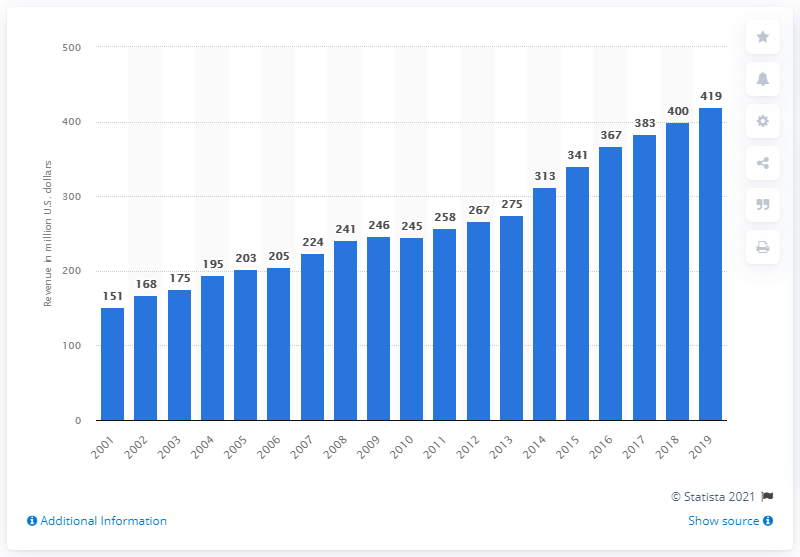Can you explain the trend in revenue growth for the Tampa Bay Buccaneers over the last decade? The chart displays a steady increase in revenue for the Tampa Bay Buccaneers over the last decade, growing from 267 million dollars in 2011 to 419 million dollars in 2019. This growth can be attributed to several factors including enhanced team performance, expanded fan base, and strategic monetary management. 